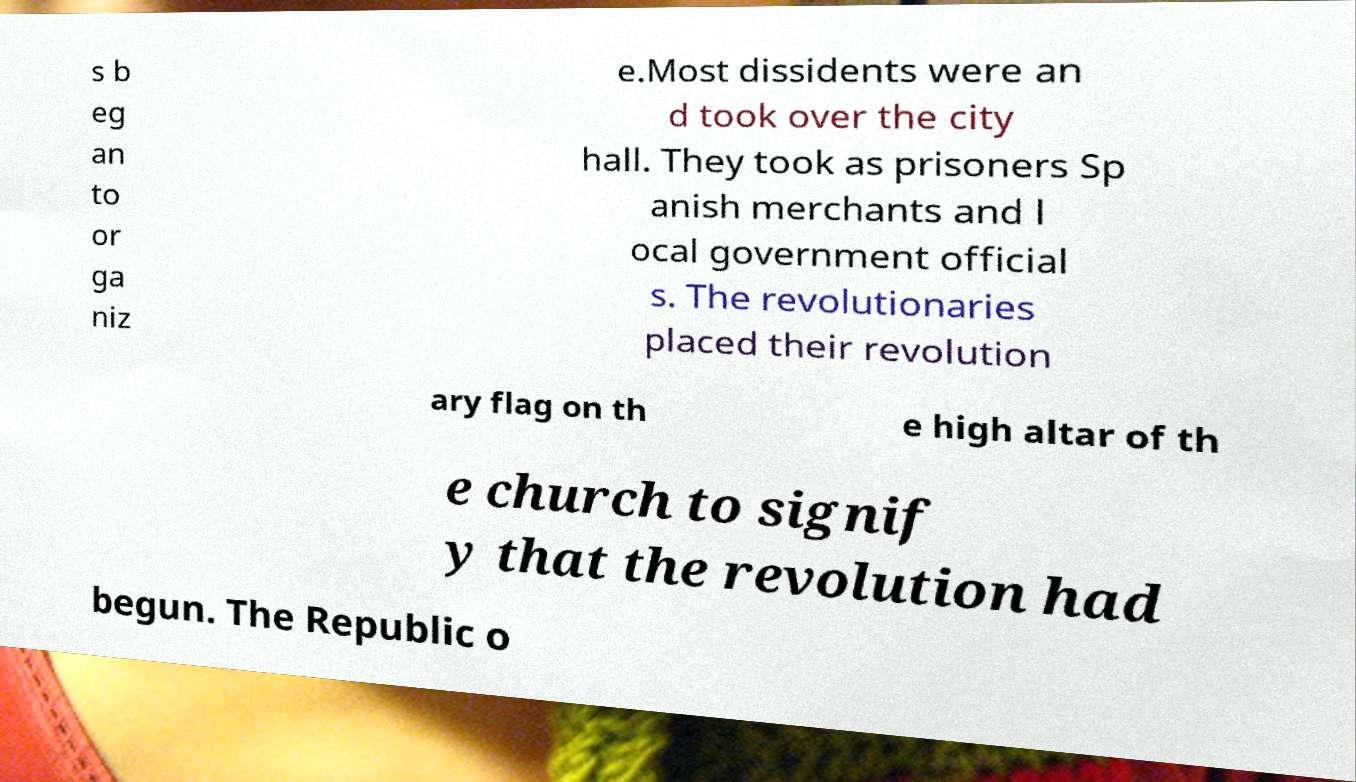There's text embedded in this image that I need extracted. Can you transcribe it verbatim? s b eg an to or ga niz e.Most dissidents were an d took over the city hall. They took as prisoners Sp anish merchants and l ocal government official s. The revolutionaries placed their revolution ary flag on th e high altar of th e church to signif y that the revolution had begun. The Republic o 